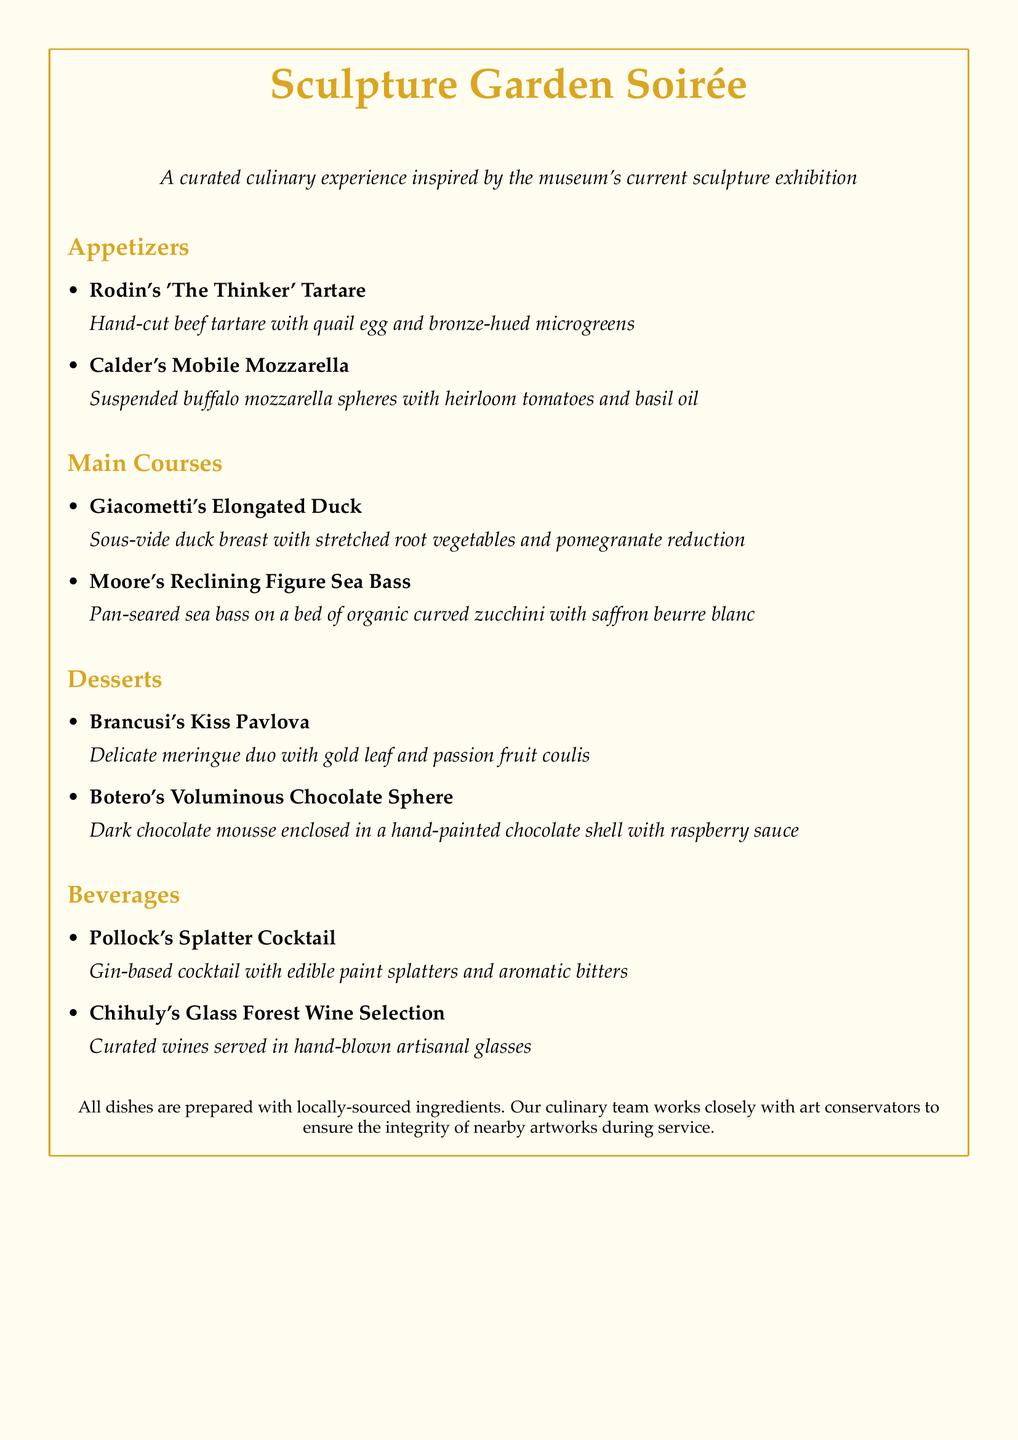What is the title of the menu? The title is located at the top of the menu, introducing the event being showcased.
Answer: Sculpture Garden Soirée Which dish is inspired by Rodin? This dish is listed under the Appetizers section and reflects Rodin's famous sculpture.
Answer: Rodin's 'The Thinker' Tartare What type of fish is featured in the main courses? This information is found in the description of the main course dish associated with Moore.
Answer: Sea Bass How many appetizers are listed on the menu? The number of appetizers can be counted in the corresponding section of the menu.
Answer: 2 What type of wine selection is mentioned in the Beverages section? This selection is highlighted in the Beverages section and reflects the art theme.
Answer: Chihuly's Glass Forest Wine Selection Which dessert includes chocolate? This is a key point mentioned in the Desserts section, focusing on a specific ingredient.
Answer: Botero's Voluminous Chocolate Sphere What is the main ingredient in Calder's Mobile Mozzarella? The description specifies the primary component of this appetizer dish.
Answer: Buffalo mozzarella What culinary approach is emphasized in the preparation of all dishes? This is stated at the bottom of the menu and relates to the ethos behind dish preparation.
Answer: Locally-sourced ingredients 